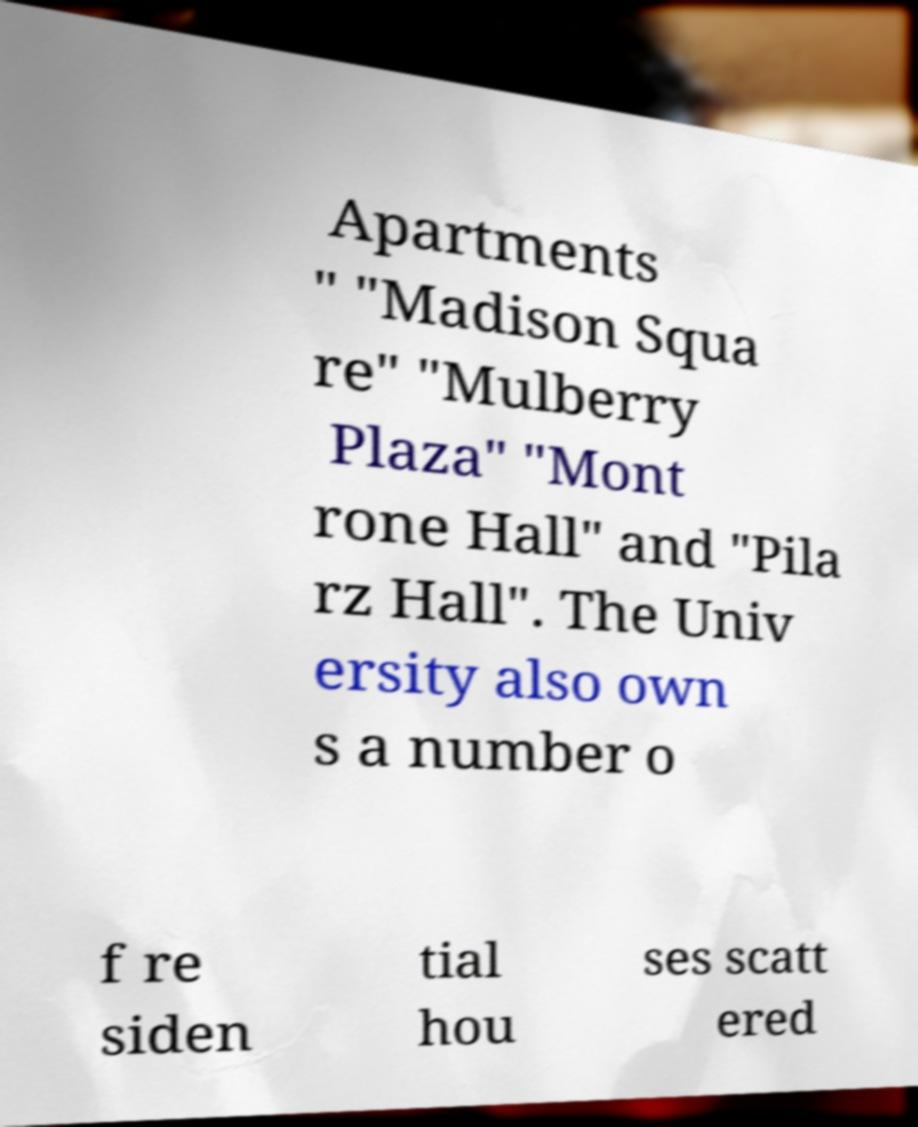I need the written content from this picture converted into text. Can you do that? Apartments " "Madison Squa re" "Mulberry Plaza" "Mont rone Hall" and "Pila rz Hall". The Univ ersity also own s a number o f re siden tial hou ses scatt ered 